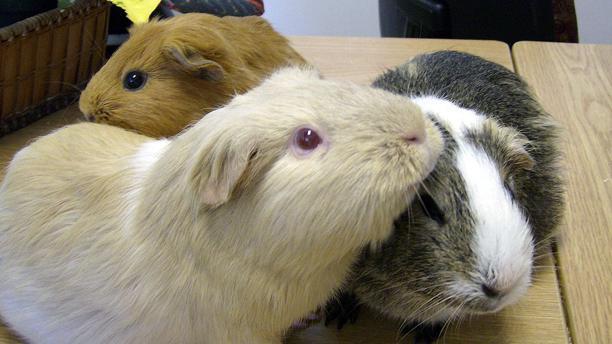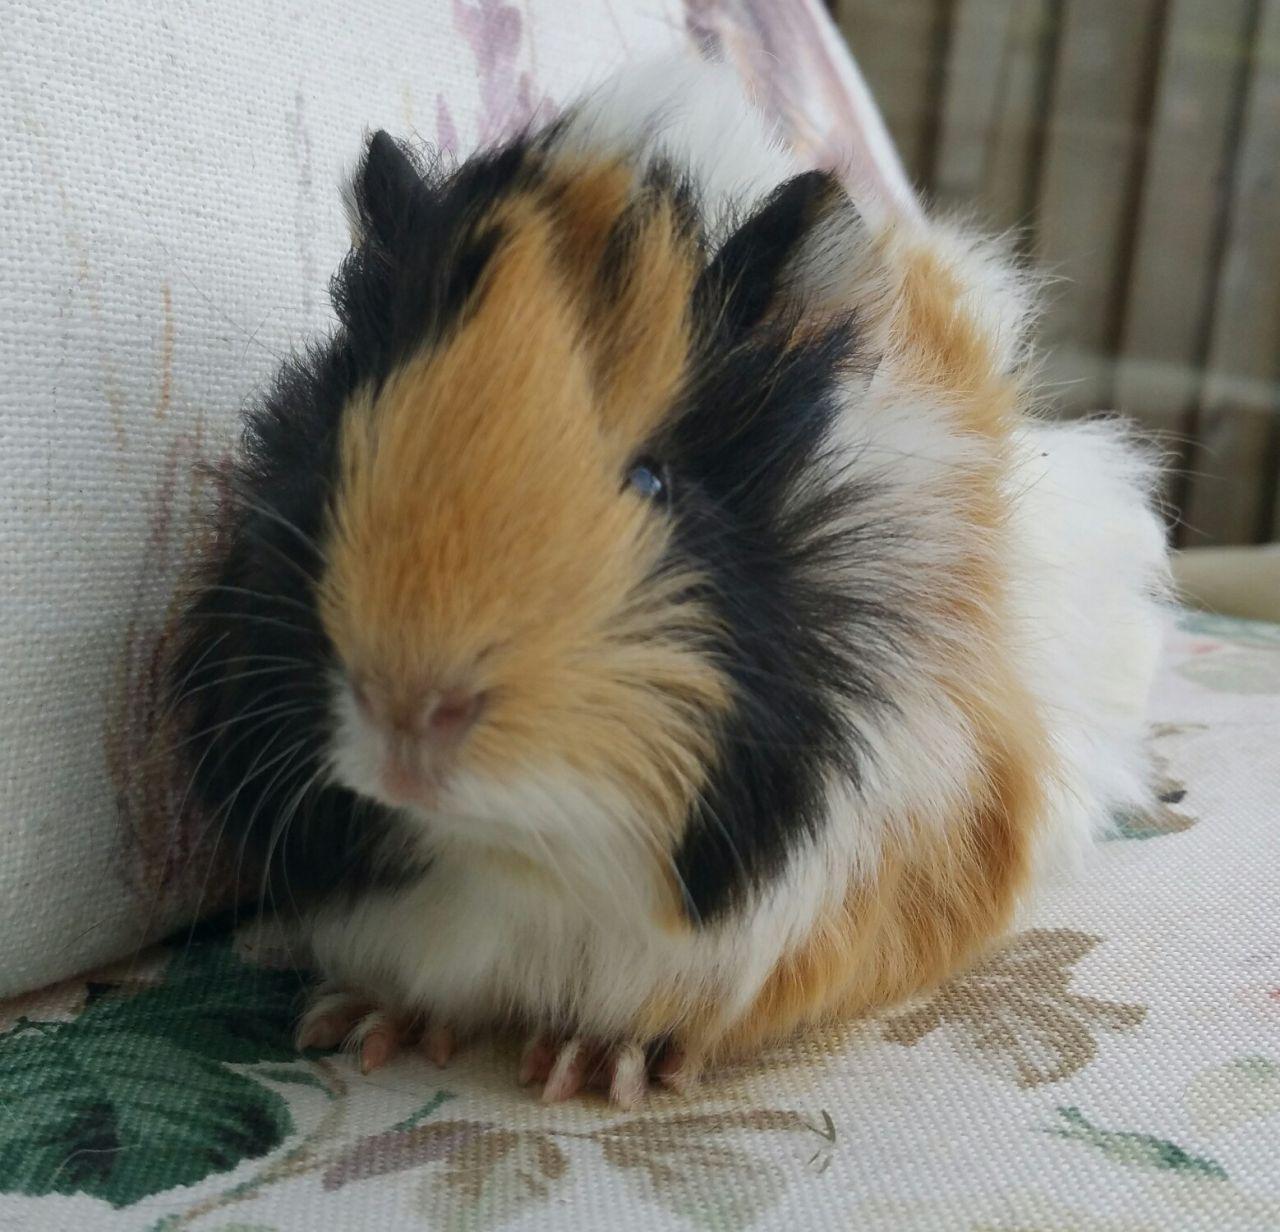The first image is the image on the left, the second image is the image on the right. Given the left and right images, does the statement "There are three guinea pigs huddled up closely together in one picture of both pairs." hold true? Answer yes or no. Yes. The first image is the image on the left, the second image is the image on the right. For the images shown, is this caption "All of the four hamsters have different color patterns and none of them are eating." true? Answer yes or no. Yes. 